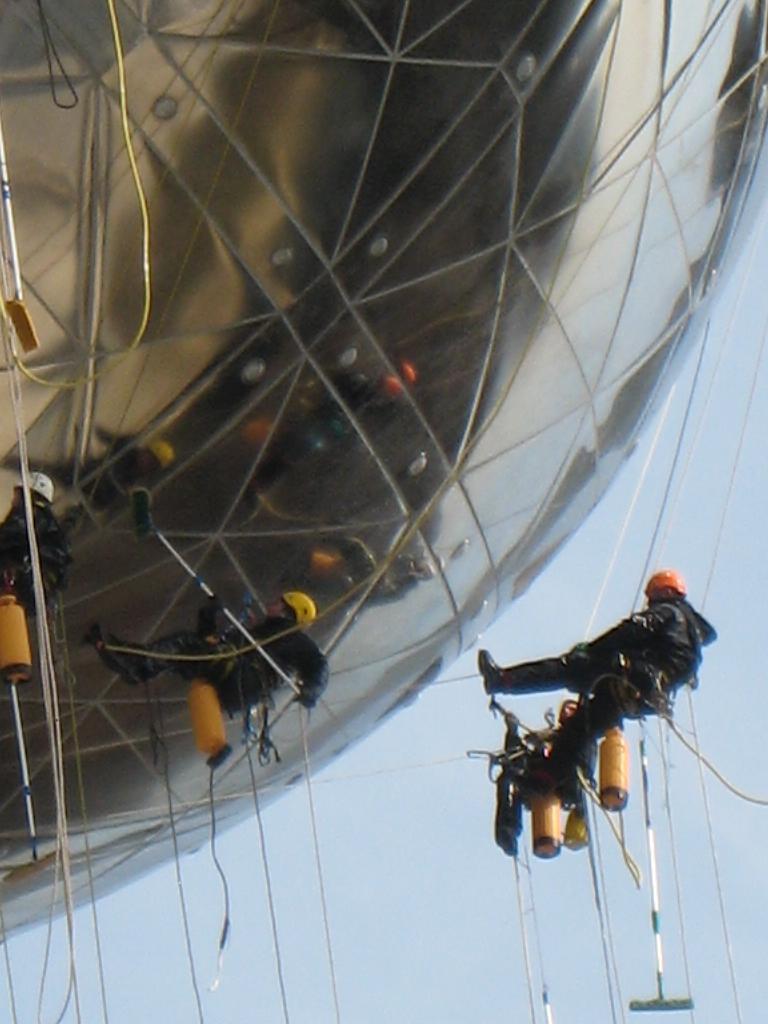Please provide a concise description of this image. In this image we can see a building on the left side of the image and there are few people carrying objects looks like they are cleaning the building. 